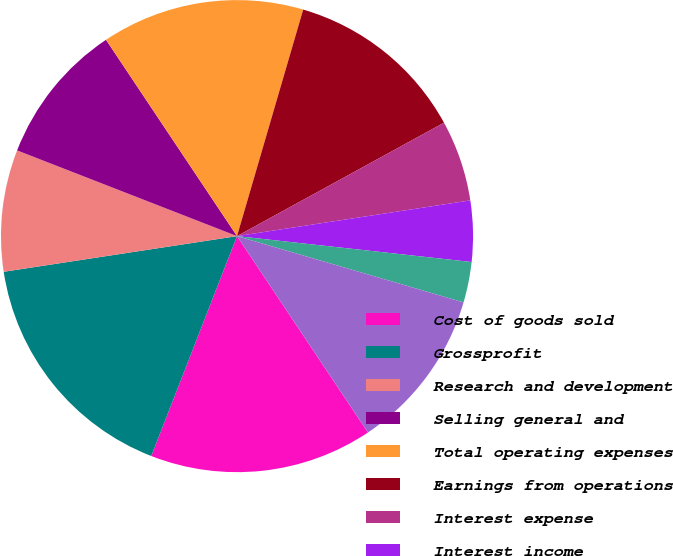<chart> <loc_0><loc_0><loc_500><loc_500><pie_chart><fcel>Cost of goods sold<fcel>Grossprofit<fcel>Research and development<fcel>Selling general and<fcel>Total operating expenses<fcel>Earnings from operations<fcel>Interest expense<fcel>Interest income<fcel>Other(income)expensenet<fcel>Earningsbeforeincometaxes<nl><fcel>15.28%<fcel>16.67%<fcel>8.33%<fcel>9.72%<fcel>13.89%<fcel>12.5%<fcel>5.56%<fcel>4.17%<fcel>2.78%<fcel>11.11%<nl></chart> 